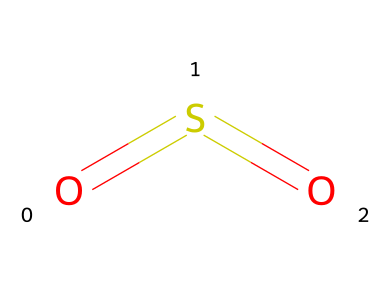What is the chemical name of this compound? The SMILES representation O=S=O indicates a molecule of sulfur dioxide, where "S" stands for sulfur and "O" stands for oxygen.
Answer: sulfur dioxide How many oxygen atoms are present in this molecule? The structure O=S=O shows that there are two "O" atoms attached to the sulfur atom.
Answer: 2 What type of bonds connect the sulfur atom to the oxygen atoms? The SMILES notation O=S=O reveals that sulfur is bonded to the two oxygen atoms by double bonds, shown by the "=" sign.
Answer: double bonds What is the oxidation state of sulfur in sulfur dioxide? In sulfur dioxide, the sulfur atom is bonded to two oxygens, and its oxidation state can be calculated as +4, which can typically be determined by considering the usual oxidation states of oxygen and overall charge neutrality.
Answer: +4 What is a common environmental effect of sulfur dioxide? Sulfur dioxide is a significant air pollutant that can lead to acid rain, which negatively impacts ecosystems.
Answer: acid rain Can sulfur dioxide undergo oxidation reactions? Yes, sulfur dioxide can undergo oxidation to form sulfur trioxide, a process usually facilitated by environmental conditions or other reactants.
Answer: yes 